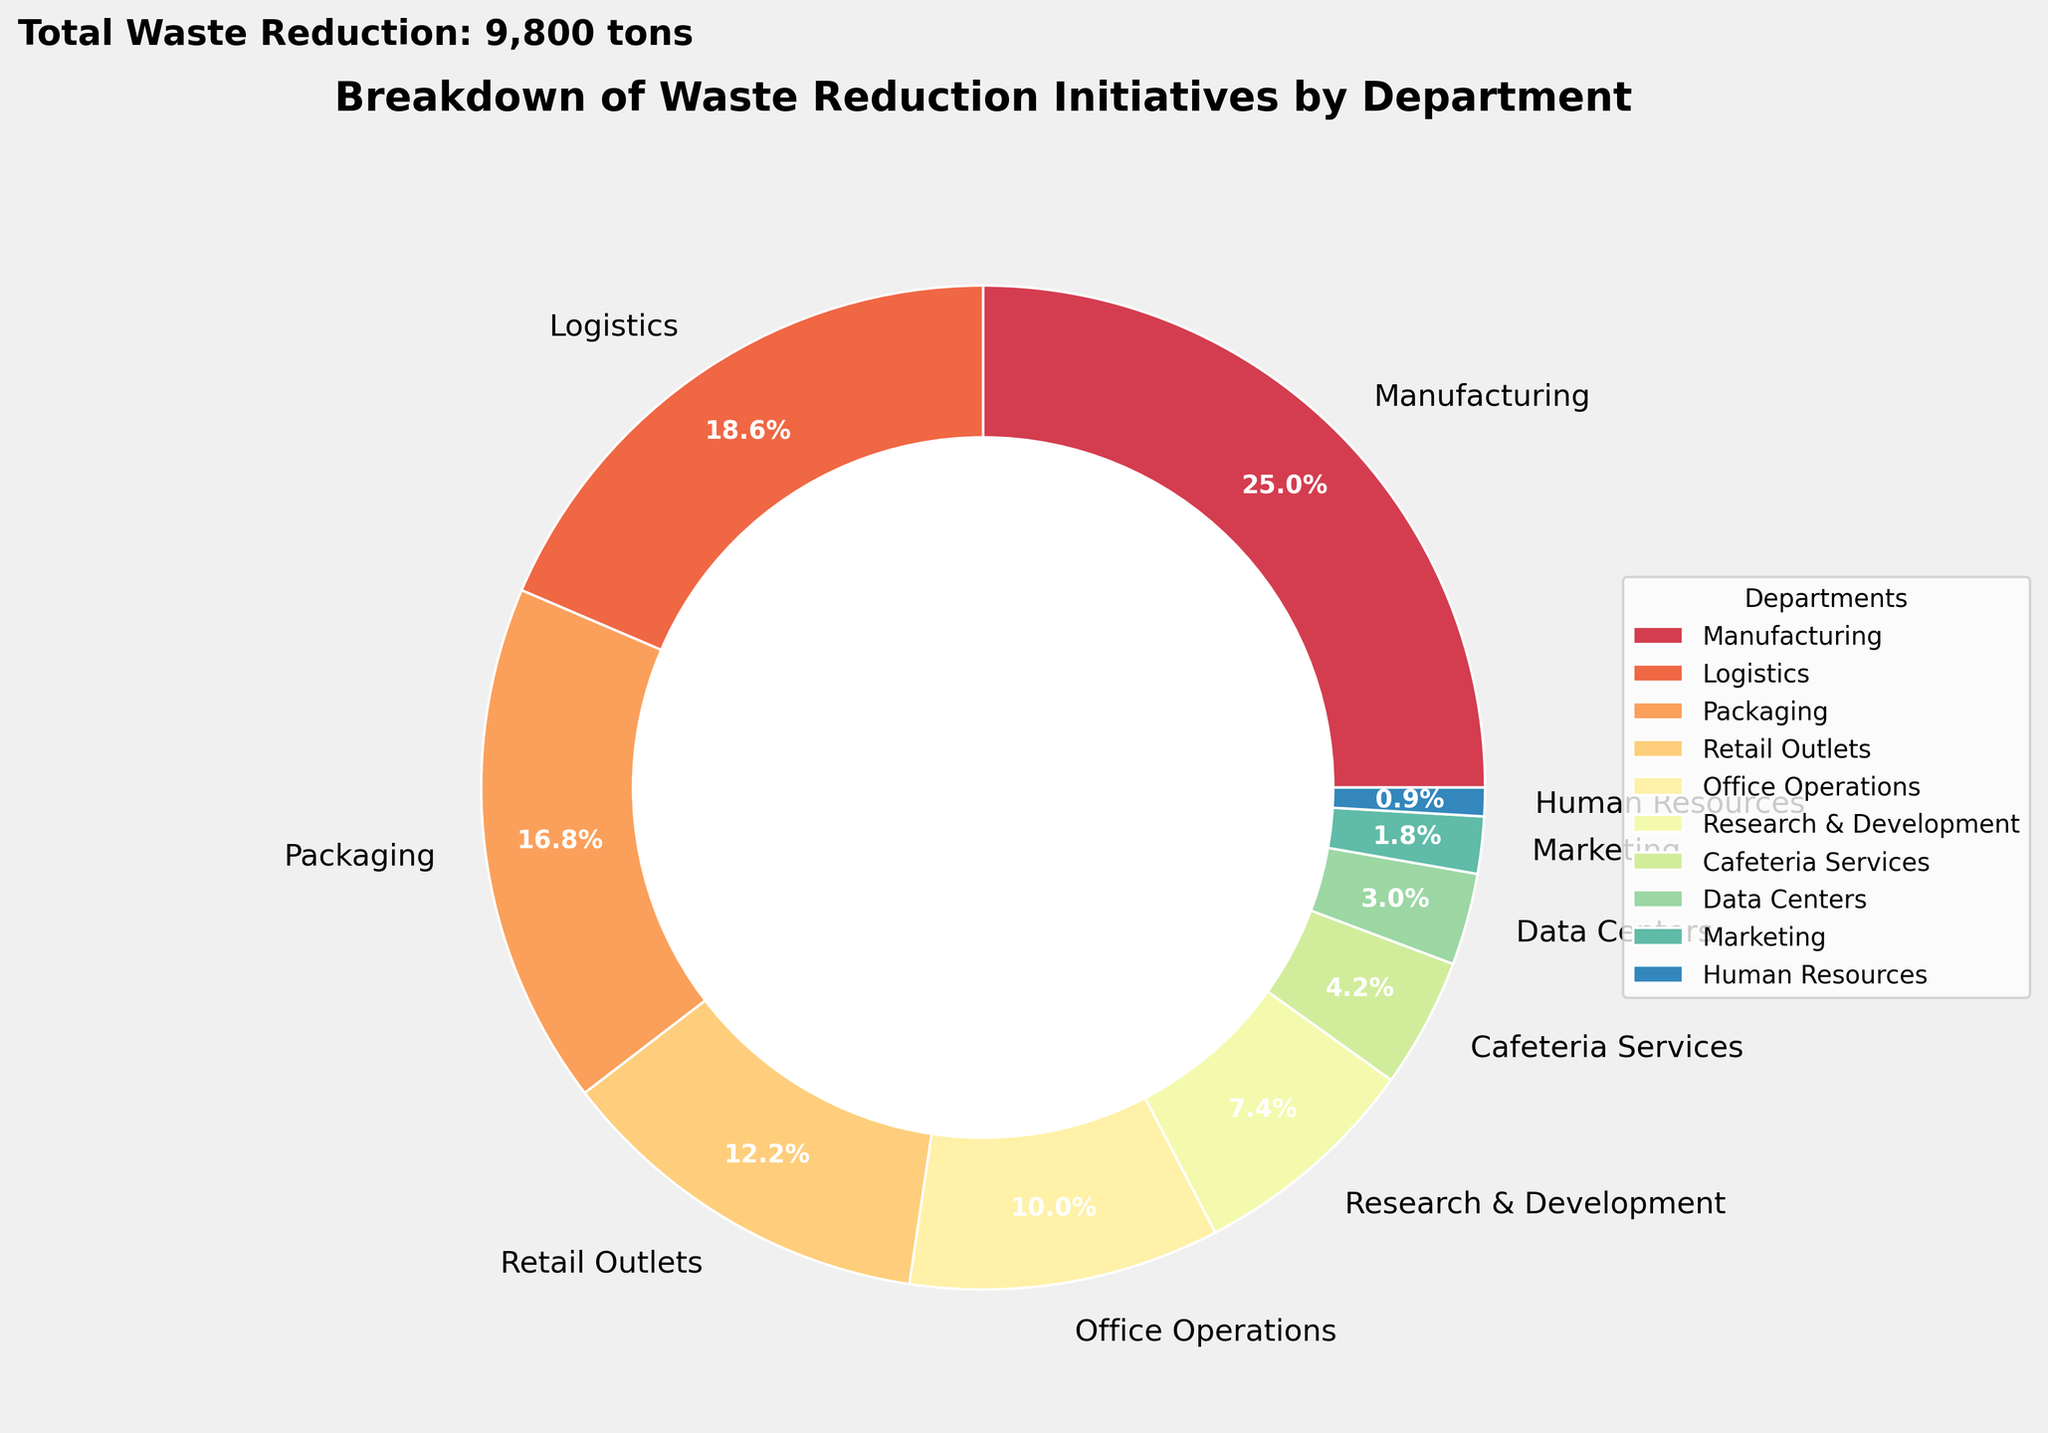What department achieved the highest waste reduction? The biggest slice in the pie chart represents Manufacturing, which achieved the highest waste reduction.
Answer: Manufacturing What is the total percentage of waste reduction achieved by Office Operations and Research & Development combined? From the chart, Office Operations and Research & Development have 9.6% and 7.1% respectively. Adding them together, 9.6% + 7.1% = 16.7%.
Answer: 16.7% Which department reduced waste less, Cafeteria Services or Data Centers? The chart shows Cafeteria Services with 4.0% and Data Centers with 2.8%. Since 2.8% is less than 4.0%, Data Centers reduced less waste.
Answer: Data Centers By how much did the Logistics department exceed the waste reduction of the Packaging department? Logistics has 17.2% and Packaging has 15.6%. The difference is 17.2% - 15.6% = 1.6%.
Answer: 1.6% Which departments have a waste reduction percentage less than 5%? The chart shows Data Centers, Marketing, and Human Resources have percentages of 2.8%, 1.7%, and 0.9% respectively.
Answer: Data Centers, Marketing, Human Resources What is the average percentage of waste reduction for the Manufacturing, Logistics, and Packaging departments? The percentage for these departments are 23.1%, 17.2%, and 15.6% respectively. Their average is (23.1 + 17.2 + 15.6) / 3 = 18.63%.
Answer: 18.63% Which department, Retail Outlets or Office Operations, has a greater contribution to waste reduction initiatives? The pie chart shows that Retail Outlets have 11.3% and Office Operations have 9.2%. Retail Outlets have a greater contribution.
Answer: Retail Outlets How do the waste reductions of both Marketing and Human Resources together compare to that of Cafeteria Services? Marketing and Human Resources together have 1.7% + 0.9% = 2.6%, while Cafeteria Services have 4.0%. Thus, Cafeteria Services have a greater percentage.
Answer: Cafeteria Services What is the contribution of non-manufacturing departments to waste reduction, excluding the Manufacturing department? Excluding Manufacturing at 27.6%, summing up the percentages of the other departments: Logistics 20.5%, Office 11.0%, R&D 8.2%, Retail 9.5%, Packaging 8.6%, Cafeteria 2.1%, Data Centers 1.5%, Marketing 0.9%, Human Resources 0.3% gives a total of 67.4%.
Answer: 67.4% 